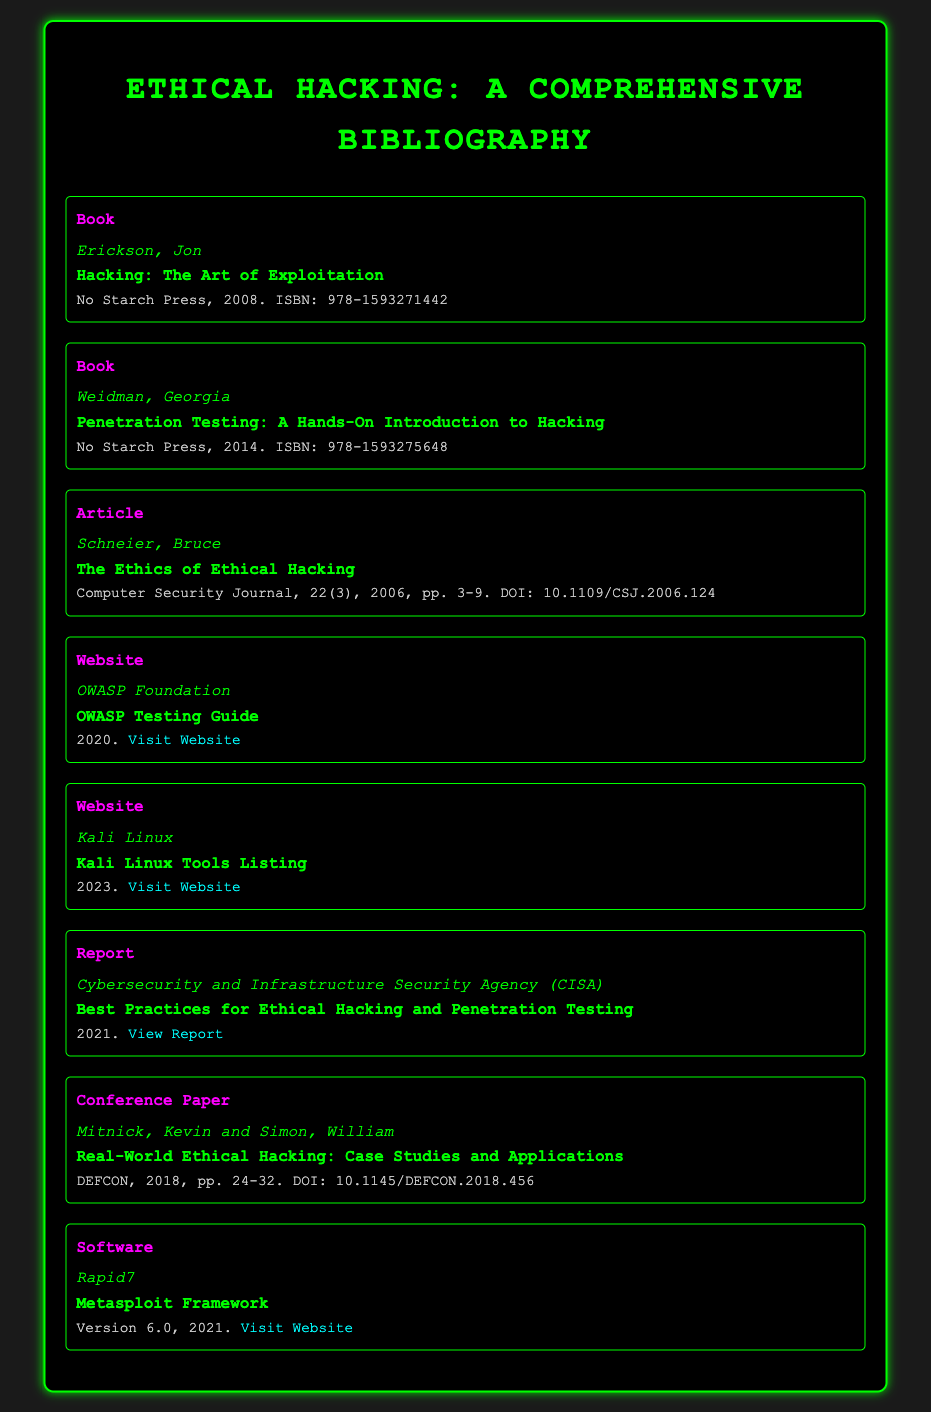What is the title of Jon Erickson's book? The title of Jon Erickson's book is found in the bibliography item under his name, which is "Hacking: The Art of Exploitation."
Answer: Hacking: The Art of Exploitation Who is the author of "Penetration Testing: A Hands-On Introduction to Hacking"? The author of "Penetration Testing: A Hands-On Introduction to Hacking" is identified in the bibliography as Georgia Weidman.
Answer: Georgia Weidman What type of document is "The Ethics of Ethical Hacking"? This title is categorized under the document type in the bibliography, which specifies it as an Article.
Answer: Article In what year was the OWASP Testing Guide published? The year of publication for the OWASP Testing Guide is stated in the bibliography as 2020.
Answer: 2020 How many authors contributed to the conference paper titled "Real-World Ethical Hacking: Case Studies and Applications"? The bibliographic entry indicates that this conference paper was authored by two individuals, Kevin Mitnick and William Simon.
Answer: Two What is the ISBN for "Hacking: The Art of Exploitation"? The ISBN for "Hacking: The Art of Exploitation" is included in the details, which is 978-1593271442.
Answer: 978-1593271442 What is the title of the report published by CISA? The CISA report title is provided in the bibliography as "Best Practices for Ethical Hacking and Penetration Testing."
Answer: Best Practices for Ethical Hacking and Penetration Testing Which framework version does the Metasploit documentation refer to? The version number of the Metasploit Framework is stated in the document as 6.0.
Answer: 6.0 